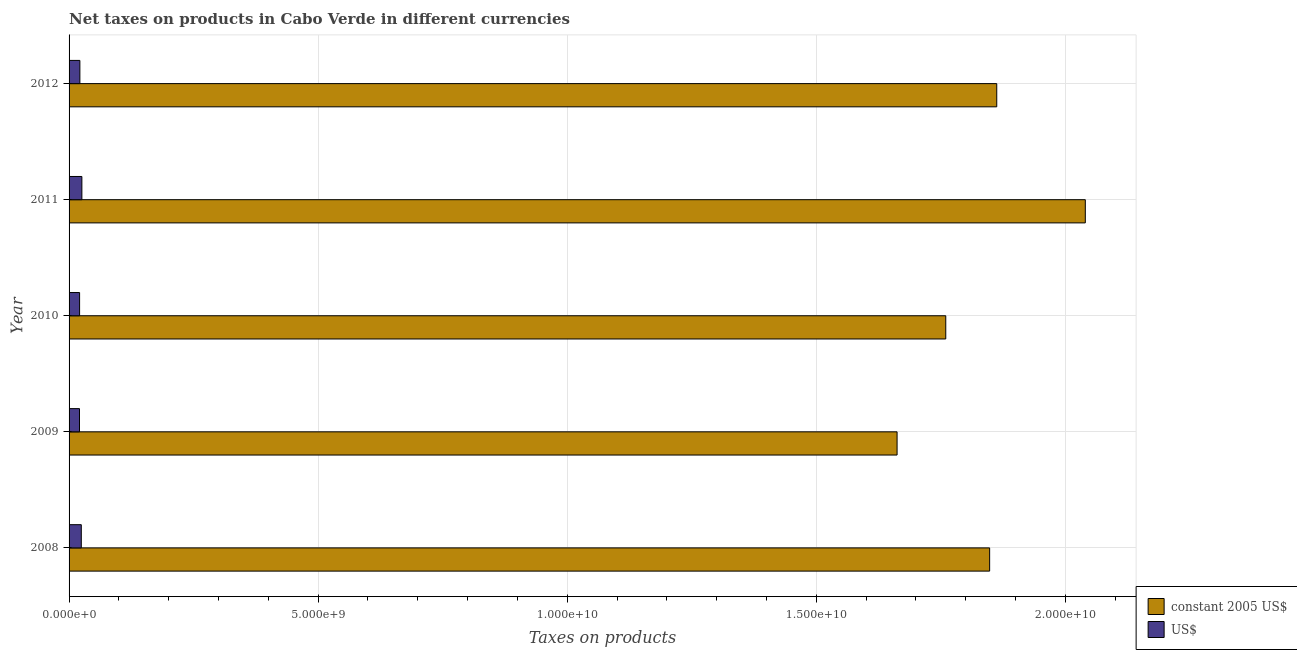How many different coloured bars are there?
Provide a short and direct response. 2. How many groups of bars are there?
Ensure brevity in your answer.  5. Are the number of bars on each tick of the Y-axis equal?
Your answer should be compact. Yes. How many bars are there on the 2nd tick from the top?
Provide a succinct answer. 2. What is the label of the 1st group of bars from the top?
Your answer should be very brief. 2012. In how many cases, is the number of bars for a given year not equal to the number of legend labels?
Ensure brevity in your answer.  0. What is the net taxes in us$ in 2011?
Your answer should be very brief. 2.57e+08. Across all years, what is the maximum net taxes in constant 2005 us$?
Keep it short and to the point. 2.04e+1. Across all years, what is the minimum net taxes in constant 2005 us$?
Your answer should be very brief. 1.66e+1. What is the total net taxes in us$ in the graph?
Provide a succinct answer. 1.14e+09. What is the difference between the net taxes in us$ in 2008 and that in 2010?
Provide a succinct answer. 3.41e+07. What is the difference between the net taxes in us$ in 2009 and the net taxes in constant 2005 us$ in 2012?
Offer a terse response. -1.84e+1. What is the average net taxes in us$ per year?
Offer a terse response. 2.28e+08. In the year 2009, what is the difference between the net taxes in us$ and net taxes in constant 2005 us$?
Ensure brevity in your answer.  -1.64e+1. What is the ratio of the net taxes in us$ in 2008 to that in 2012?
Your response must be concise. 1.13. Is the net taxes in us$ in 2010 less than that in 2012?
Provide a short and direct response. Yes. What is the difference between the highest and the second highest net taxes in constant 2005 us$?
Offer a terse response. 1.78e+09. What is the difference between the highest and the lowest net taxes in us$?
Your response must be concise. 4.78e+07. In how many years, is the net taxes in us$ greater than the average net taxes in us$ taken over all years?
Ensure brevity in your answer.  2. Is the sum of the net taxes in us$ in 2009 and 2012 greater than the maximum net taxes in constant 2005 us$ across all years?
Make the answer very short. No. What does the 2nd bar from the top in 2008 represents?
Keep it short and to the point. Constant 2005 us$. What does the 2nd bar from the bottom in 2009 represents?
Your answer should be compact. US$. How many bars are there?
Your answer should be compact. 10. Are all the bars in the graph horizontal?
Offer a very short reply. Yes. How many years are there in the graph?
Provide a succinct answer. 5. Are the values on the major ticks of X-axis written in scientific E-notation?
Your answer should be compact. Yes. Does the graph contain any zero values?
Give a very brief answer. No. Does the graph contain grids?
Your response must be concise. Yes. Where does the legend appear in the graph?
Make the answer very short. Bottom right. What is the title of the graph?
Make the answer very short. Net taxes on products in Cabo Verde in different currencies. Does "GDP at market prices" appear as one of the legend labels in the graph?
Keep it short and to the point. No. What is the label or title of the X-axis?
Ensure brevity in your answer.  Taxes on products. What is the label or title of the Y-axis?
Provide a short and direct response. Year. What is the Taxes on products of constant 2005 US$ in 2008?
Offer a very short reply. 1.85e+1. What is the Taxes on products of US$ in 2008?
Make the answer very short. 2.45e+08. What is the Taxes on products of constant 2005 US$ in 2009?
Provide a short and direct response. 1.66e+1. What is the Taxes on products in US$ in 2009?
Keep it short and to the point. 2.09e+08. What is the Taxes on products in constant 2005 US$ in 2010?
Ensure brevity in your answer.  1.76e+1. What is the Taxes on products of US$ in 2010?
Offer a terse response. 2.11e+08. What is the Taxes on products in constant 2005 US$ in 2011?
Ensure brevity in your answer.  2.04e+1. What is the Taxes on products in US$ in 2011?
Keep it short and to the point. 2.57e+08. What is the Taxes on products of constant 2005 US$ in 2012?
Keep it short and to the point. 1.86e+1. What is the Taxes on products in US$ in 2012?
Keep it short and to the point. 2.17e+08. Across all years, what is the maximum Taxes on products of constant 2005 US$?
Your response must be concise. 2.04e+1. Across all years, what is the maximum Taxes on products in US$?
Make the answer very short. 2.57e+08. Across all years, what is the minimum Taxes on products in constant 2005 US$?
Provide a short and direct response. 1.66e+1. Across all years, what is the minimum Taxes on products in US$?
Give a very brief answer. 2.09e+08. What is the total Taxes on products in constant 2005 US$ in the graph?
Keep it short and to the point. 9.17e+1. What is the total Taxes on products in US$ in the graph?
Your response must be concise. 1.14e+09. What is the difference between the Taxes on products of constant 2005 US$ in 2008 and that in 2009?
Provide a succinct answer. 1.86e+09. What is the difference between the Taxes on products of US$ in 2008 and that in 2009?
Make the answer very short. 3.61e+07. What is the difference between the Taxes on products of constant 2005 US$ in 2008 and that in 2010?
Your response must be concise. 8.81e+08. What is the difference between the Taxes on products of US$ in 2008 and that in 2010?
Provide a short and direct response. 3.41e+07. What is the difference between the Taxes on products in constant 2005 US$ in 2008 and that in 2011?
Offer a very short reply. -1.92e+09. What is the difference between the Taxes on products of US$ in 2008 and that in 2011?
Offer a terse response. -1.17e+07. What is the difference between the Taxes on products in constant 2005 US$ in 2008 and that in 2012?
Keep it short and to the point. -1.42e+08. What is the difference between the Taxes on products in US$ in 2008 and that in 2012?
Ensure brevity in your answer.  2.85e+07. What is the difference between the Taxes on products of constant 2005 US$ in 2009 and that in 2010?
Make the answer very short. -9.77e+08. What is the difference between the Taxes on products of US$ in 2009 and that in 2010?
Provide a succinct answer. -1.98e+06. What is the difference between the Taxes on products of constant 2005 US$ in 2009 and that in 2011?
Provide a short and direct response. -3.78e+09. What is the difference between the Taxes on products in US$ in 2009 and that in 2011?
Your answer should be compact. -4.78e+07. What is the difference between the Taxes on products of constant 2005 US$ in 2009 and that in 2012?
Provide a succinct answer. -2.00e+09. What is the difference between the Taxes on products of US$ in 2009 and that in 2012?
Your response must be concise. -7.58e+06. What is the difference between the Taxes on products in constant 2005 US$ in 2010 and that in 2011?
Ensure brevity in your answer.  -2.80e+09. What is the difference between the Taxes on products of US$ in 2010 and that in 2011?
Give a very brief answer. -4.58e+07. What is the difference between the Taxes on products of constant 2005 US$ in 2010 and that in 2012?
Your answer should be very brief. -1.02e+09. What is the difference between the Taxes on products of US$ in 2010 and that in 2012?
Keep it short and to the point. -5.61e+06. What is the difference between the Taxes on products in constant 2005 US$ in 2011 and that in 2012?
Keep it short and to the point. 1.78e+09. What is the difference between the Taxes on products of US$ in 2011 and that in 2012?
Your response must be concise. 4.02e+07. What is the difference between the Taxes on products in constant 2005 US$ in 2008 and the Taxes on products in US$ in 2009?
Your response must be concise. 1.83e+1. What is the difference between the Taxes on products in constant 2005 US$ in 2008 and the Taxes on products in US$ in 2010?
Your answer should be compact. 1.83e+1. What is the difference between the Taxes on products in constant 2005 US$ in 2008 and the Taxes on products in US$ in 2011?
Make the answer very short. 1.82e+1. What is the difference between the Taxes on products of constant 2005 US$ in 2008 and the Taxes on products of US$ in 2012?
Give a very brief answer. 1.83e+1. What is the difference between the Taxes on products of constant 2005 US$ in 2009 and the Taxes on products of US$ in 2010?
Ensure brevity in your answer.  1.64e+1. What is the difference between the Taxes on products of constant 2005 US$ in 2009 and the Taxes on products of US$ in 2011?
Offer a terse response. 1.64e+1. What is the difference between the Taxes on products of constant 2005 US$ in 2009 and the Taxes on products of US$ in 2012?
Ensure brevity in your answer.  1.64e+1. What is the difference between the Taxes on products in constant 2005 US$ in 2010 and the Taxes on products in US$ in 2011?
Provide a succinct answer. 1.73e+1. What is the difference between the Taxes on products of constant 2005 US$ in 2010 and the Taxes on products of US$ in 2012?
Give a very brief answer. 1.74e+1. What is the difference between the Taxes on products in constant 2005 US$ in 2011 and the Taxes on products in US$ in 2012?
Give a very brief answer. 2.02e+1. What is the average Taxes on products in constant 2005 US$ per year?
Provide a succinct answer. 1.83e+1. What is the average Taxes on products in US$ per year?
Provide a short and direct response. 2.28e+08. In the year 2008, what is the difference between the Taxes on products of constant 2005 US$ and Taxes on products of US$?
Give a very brief answer. 1.82e+1. In the year 2009, what is the difference between the Taxes on products of constant 2005 US$ and Taxes on products of US$?
Give a very brief answer. 1.64e+1. In the year 2010, what is the difference between the Taxes on products of constant 2005 US$ and Taxes on products of US$?
Keep it short and to the point. 1.74e+1. In the year 2011, what is the difference between the Taxes on products in constant 2005 US$ and Taxes on products in US$?
Provide a succinct answer. 2.01e+1. In the year 2012, what is the difference between the Taxes on products of constant 2005 US$ and Taxes on products of US$?
Your answer should be very brief. 1.84e+1. What is the ratio of the Taxes on products of constant 2005 US$ in 2008 to that in 2009?
Provide a short and direct response. 1.11. What is the ratio of the Taxes on products of US$ in 2008 to that in 2009?
Keep it short and to the point. 1.17. What is the ratio of the Taxes on products in US$ in 2008 to that in 2010?
Offer a very short reply. 1.16. What is the ratio of the Taxes on products of constant 2005 US$ in 2008 to that in 2011?
Make the answer very short. 0.91. What is the ratio of the Taxes on products of US$ in 2008 to that in 2011?
Your answer should be compact. 0.95. What is the ratio of the Taxes on products in US$ in 2008 to that in 2012?
Ensure brevity in your answer.  1.13. What is the ratio of the Taxes on products in constant 2005 US$ in 2009 to that in 2010?
Keep it short and to the point. 0.94. What is the ratio of the Taxes on products of US$ in 2009 to that in 2010?
Your answer should be compact. 0.99. What is the ratio of the Taxes on products of constant 2005 US$ in 2009 to that in 2011?
Offer a very short reply. 0.81. What is the ratio of the Taxes on products of US$ in 2009 to that in 2011?
Provide a succinct answer. 0.81. What is the ratio of the Taxes on products in constant 2005 US$ in 2009 to that in 2012?
Offer a very short reply. 0.89. What is the ratio of the Taxes on products in US$ in 2009 to that in 2012?
Provide a succinct answer. 0.96. What is the ratio of the Taxes on products of constant 2005 US$ in 2010 to that in 2011?
Offer a very short reply. 0.86. What is the ratio of the Taxes on products in US$ in 2010 to that in 2011?
Ensure brevity in your answer.  0.82. What is the ratio of the Taxes on products in constant 2005 US$ in 2010 to that in 2012?
Your answer should be very brief. 0.95. What is the ratio of the Taxes on products of US$ in 2010 to that in 2012?
Make the answer very short. 0.97. What is the ratio of the Taxes on products of constant 2005 US$ in 2011 to that in 2012?
Your answer should be compact. 1.1. What is the ratio of the Taxes on products of US$ in 2011 to that in 2012?
Give a very brief answer. 1.19. What is the difference between the highest and the second highest Taxes on products of constant 2005 US$?
Provide a succinct answer. 1.78e+09. What is the difference between the highest and the second highest Taxes on products of US$?
Provide a short and direct response. 1.17e+07. What is the difference between the highest and the lowest Taxes on products in constant 2005 US$?
Offer a terse response. 3.78e+09. What is the difference between the highest and the lowest Taxes on products in US$?
Give a very brief answer. 4.78e+07. 